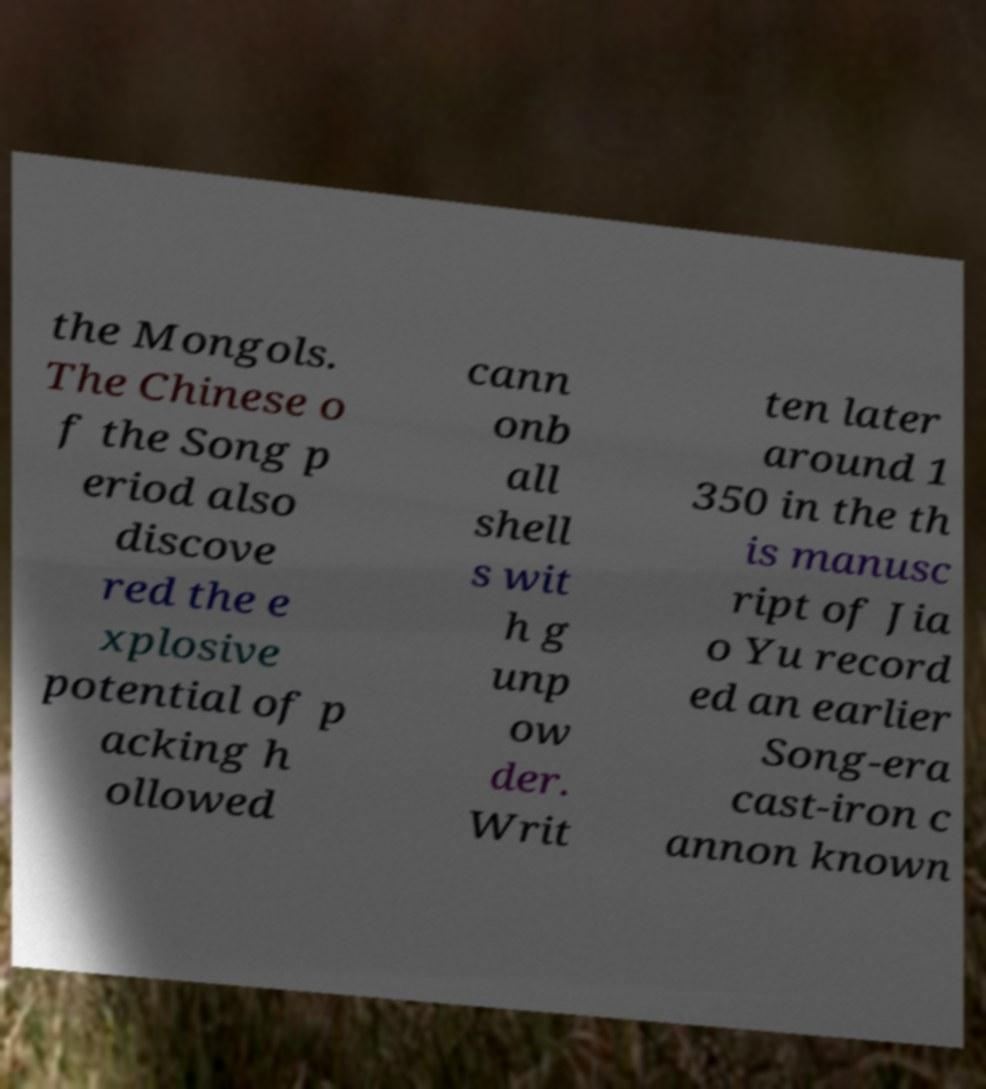Please identify and transcribe the text found in this image. the Mongols. The Chinese o f the Song p eriod also discove red the e xplosive potential of p acking h ollowed cann onb all shell s wit h g unp ow der. Writ ten later around 1 350 in the th is manusc ript of Jia o Yu record ed an earlier Song-era cast-iron c annon known 